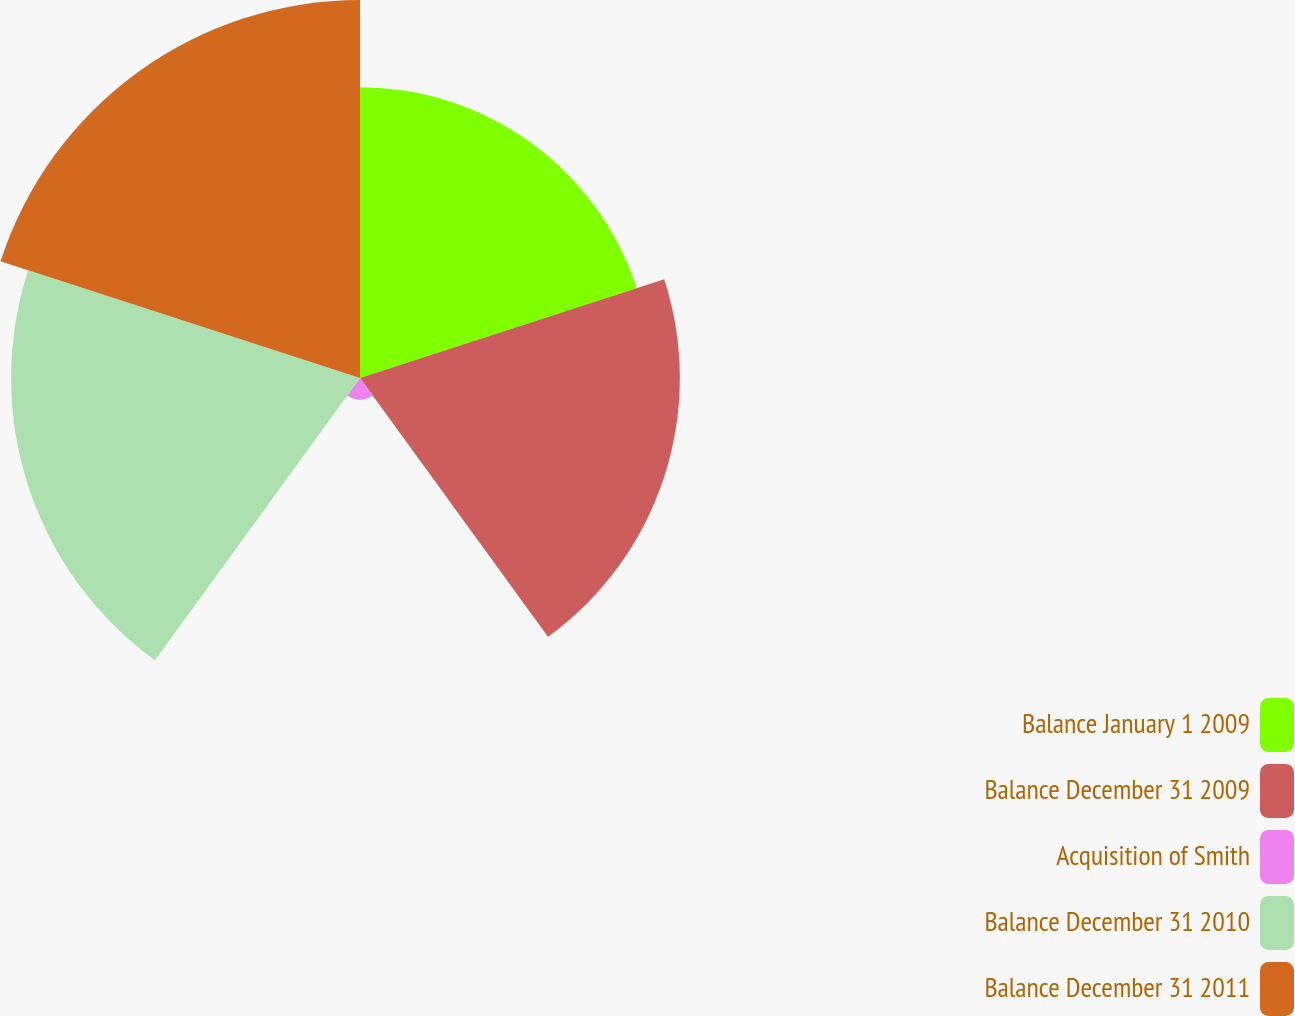Convert chart. <chart><loc_0><loc_0><loc_500><loc_500><pie_chart><fcel>Balance January 1 2009<fcel>Balance December 31 2009<fcel>Acquisition of Smith<fcel>Balance December 31 2010<fcel>Balance December 31 2011<nl><fcel>21.39%<fcel>23.53%<fcel>1.6%<fcel>25.67%<fcel>27.81%<nl></chart> 